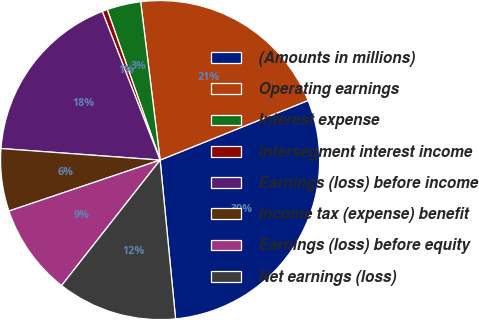Convert chart. <chart><loc_0><loc_0><loc_500><loc_500><pie_chart><fcel>(Amounts in millions)<fcel>Operating earnings<fcel>Interest expense<fcel>Intersegment interest income<fcel>Earnings (loss) before income<fcel>Income tax (expense) benefit<fcel>Earnings (loss) before equity<fcel>Net earnings (loss)<nl><fcel>29.55%<fcel>20.85%<fcel>3.43%<fcel>0.53%<fcel>17.94%<fcel>6.33%<fcel>9.23%<fcel>12.14%<nl></chart> 